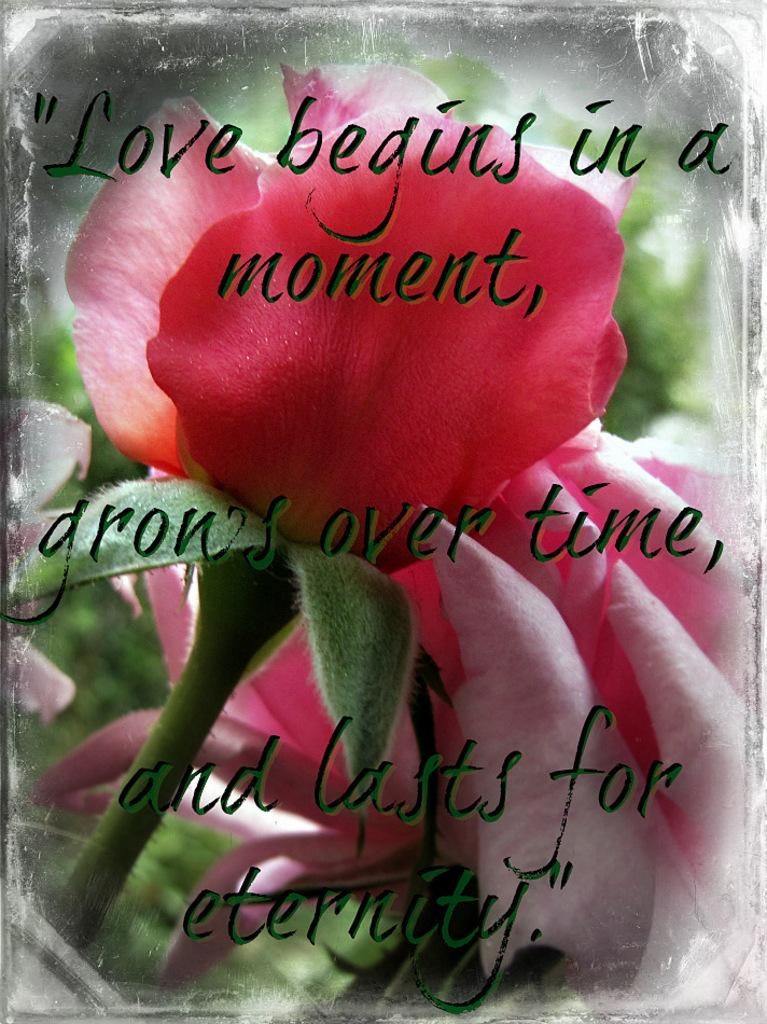What type of flower is in the image? There is a red flower in the image. What message or quote is present in the image? The quote "Love begins in a moment, grows over time and lasts for the eternity" is present in the image. What type of beef can be seen hanging from the flower in the image? There is no beef present in the image; it features a red flower and a quote about love. What color is the cobweb surrounding the flower in the image? There is no cobweb present in the image; it only features a red flower and a quote about love. 